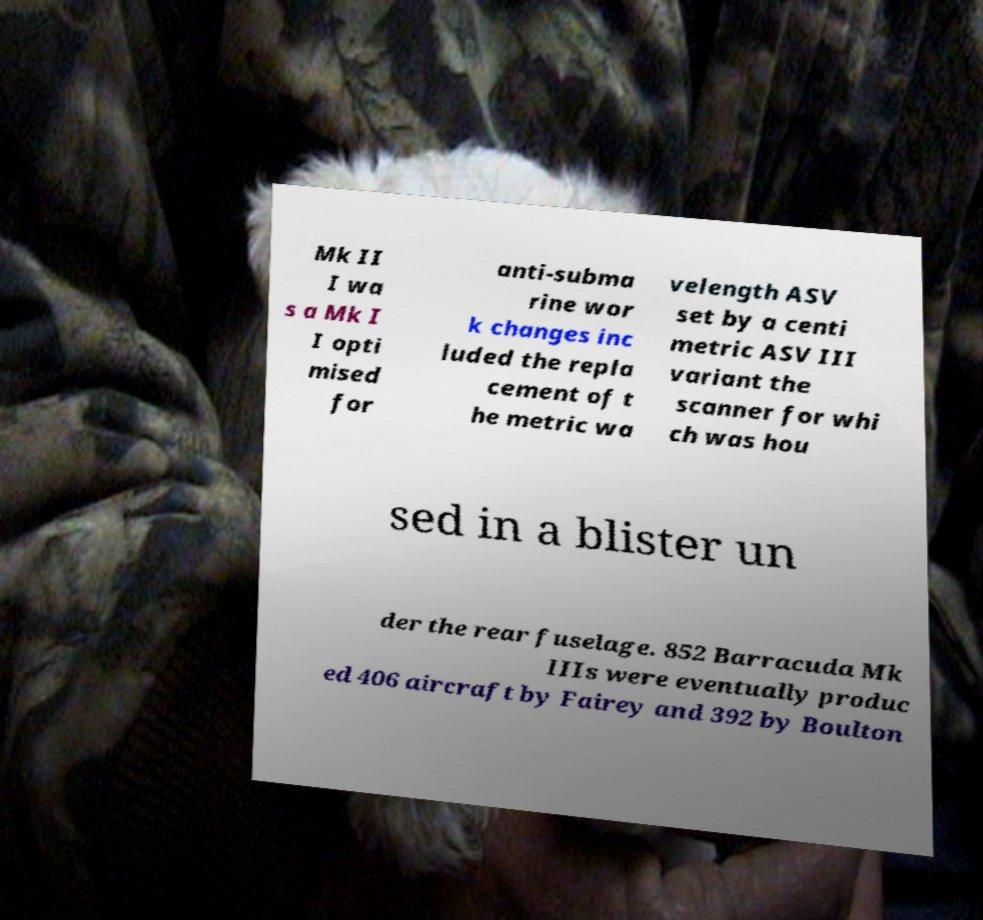Can you read and provide the text displayed in the image?This photo seems to have some interesting text. Can you extract and type it out for me? Mk II I wa s a Mk I I opti mised for anti-subma rine wor k changes inc luded the repla cement of t he metric wa velength ASV set by a centi metric ASV III variant the scanner for whi ch was hou sed in a blister un der the rear fuselage. 852 Barracuda Mk IIIs were eventually produc ed 406 aircraft by Fairey and 392 by Boulton 